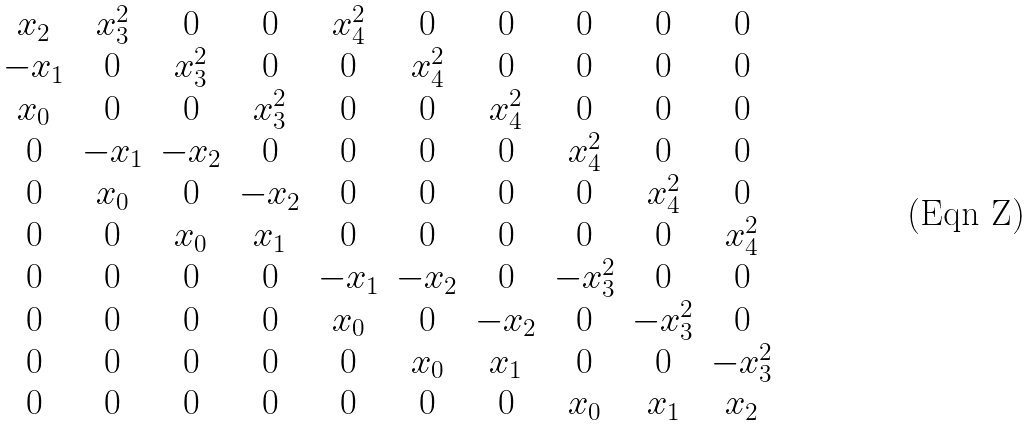<formula> <loc_0><loc_0><loc_500><loc_500>\begin{matrix} x _ { 2 } & { x } _ { 3 } ^ { 2 } & 0 & 0 & { x } _ { 4 } ^ { 2 } & 0 & 0 & 0 & 0 & 0 \\ { - { x } _ { 1 } } & 0 & { x } _ { 3 } ^ { 2 } & 0 & 0 & { x } _ { 4 } ^ { 2 } & 0 & 0 & 0 & 0 \\ { x } _ { 0 } & 0 & 0 & { x } _ { 3 } ^ { 2 } & 0 & 0 & { x } _ { 4 } ^ { 2 } & 0 & 0 & 0 \\ 0 & { - { x } _ { 1 } } & { - { x } _ { 2 } } & 0 & 0 & 0 & 0 & { x } _ { 4 } ^ { 2 } & 0 & 0 \\ 0 & { x } _ { 0 } & 0 & { - { x } _ { 2 } } & 0 & 0 & 0 & 0 & { x } _ { 4 } ^ { 2 } & 0 \\ 0 & 0 & { x } _ { 0 } & { x } _ { 1 } & 0 & 0 & 0 & 0 & 0 & { x } _ { 4 } ^ { 2 } \\ 0 & 0 & 0 & 0 & { - { x } _ { 1 } } & { - { x } _ { 2 } } & 0 & { - { x } _ { 3 } ^ { 2 } } & 0 & 0 \\ 0 & 0 & 0 & 0 & { x } _ { 0 } & 0 & { - { x } _ { 2 } } & 0 & { - { x } _ { 3 } ^ { 2 } } & 0 \\ 0 & 0 & 0 & 0 & 0 & { x } _ { 0 } & { x } _ { 1 } & 0 & 0 & { - { x } _ { 3 } ^ { 2 } } \\ 0 & 0 & 0 & 0 & 0 & 0 & 0 & { x } _ { 0 } & { x } _ { 1 } & { x } _ { 2 } \\ \end{matrix}</formula> 